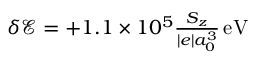Convert formula to latex. <formula><loc_0><loc_0><loc_500><loc_500>\begin{array} { r } { { \delta { { \mathcal { E } } } } = + 1 . 1 \times 1 0 ^ { 5 } \frac { S _ { z } } { | e | a _ { 0 } ^ { 3 } } { \, e V } } \end{array}</formula> 